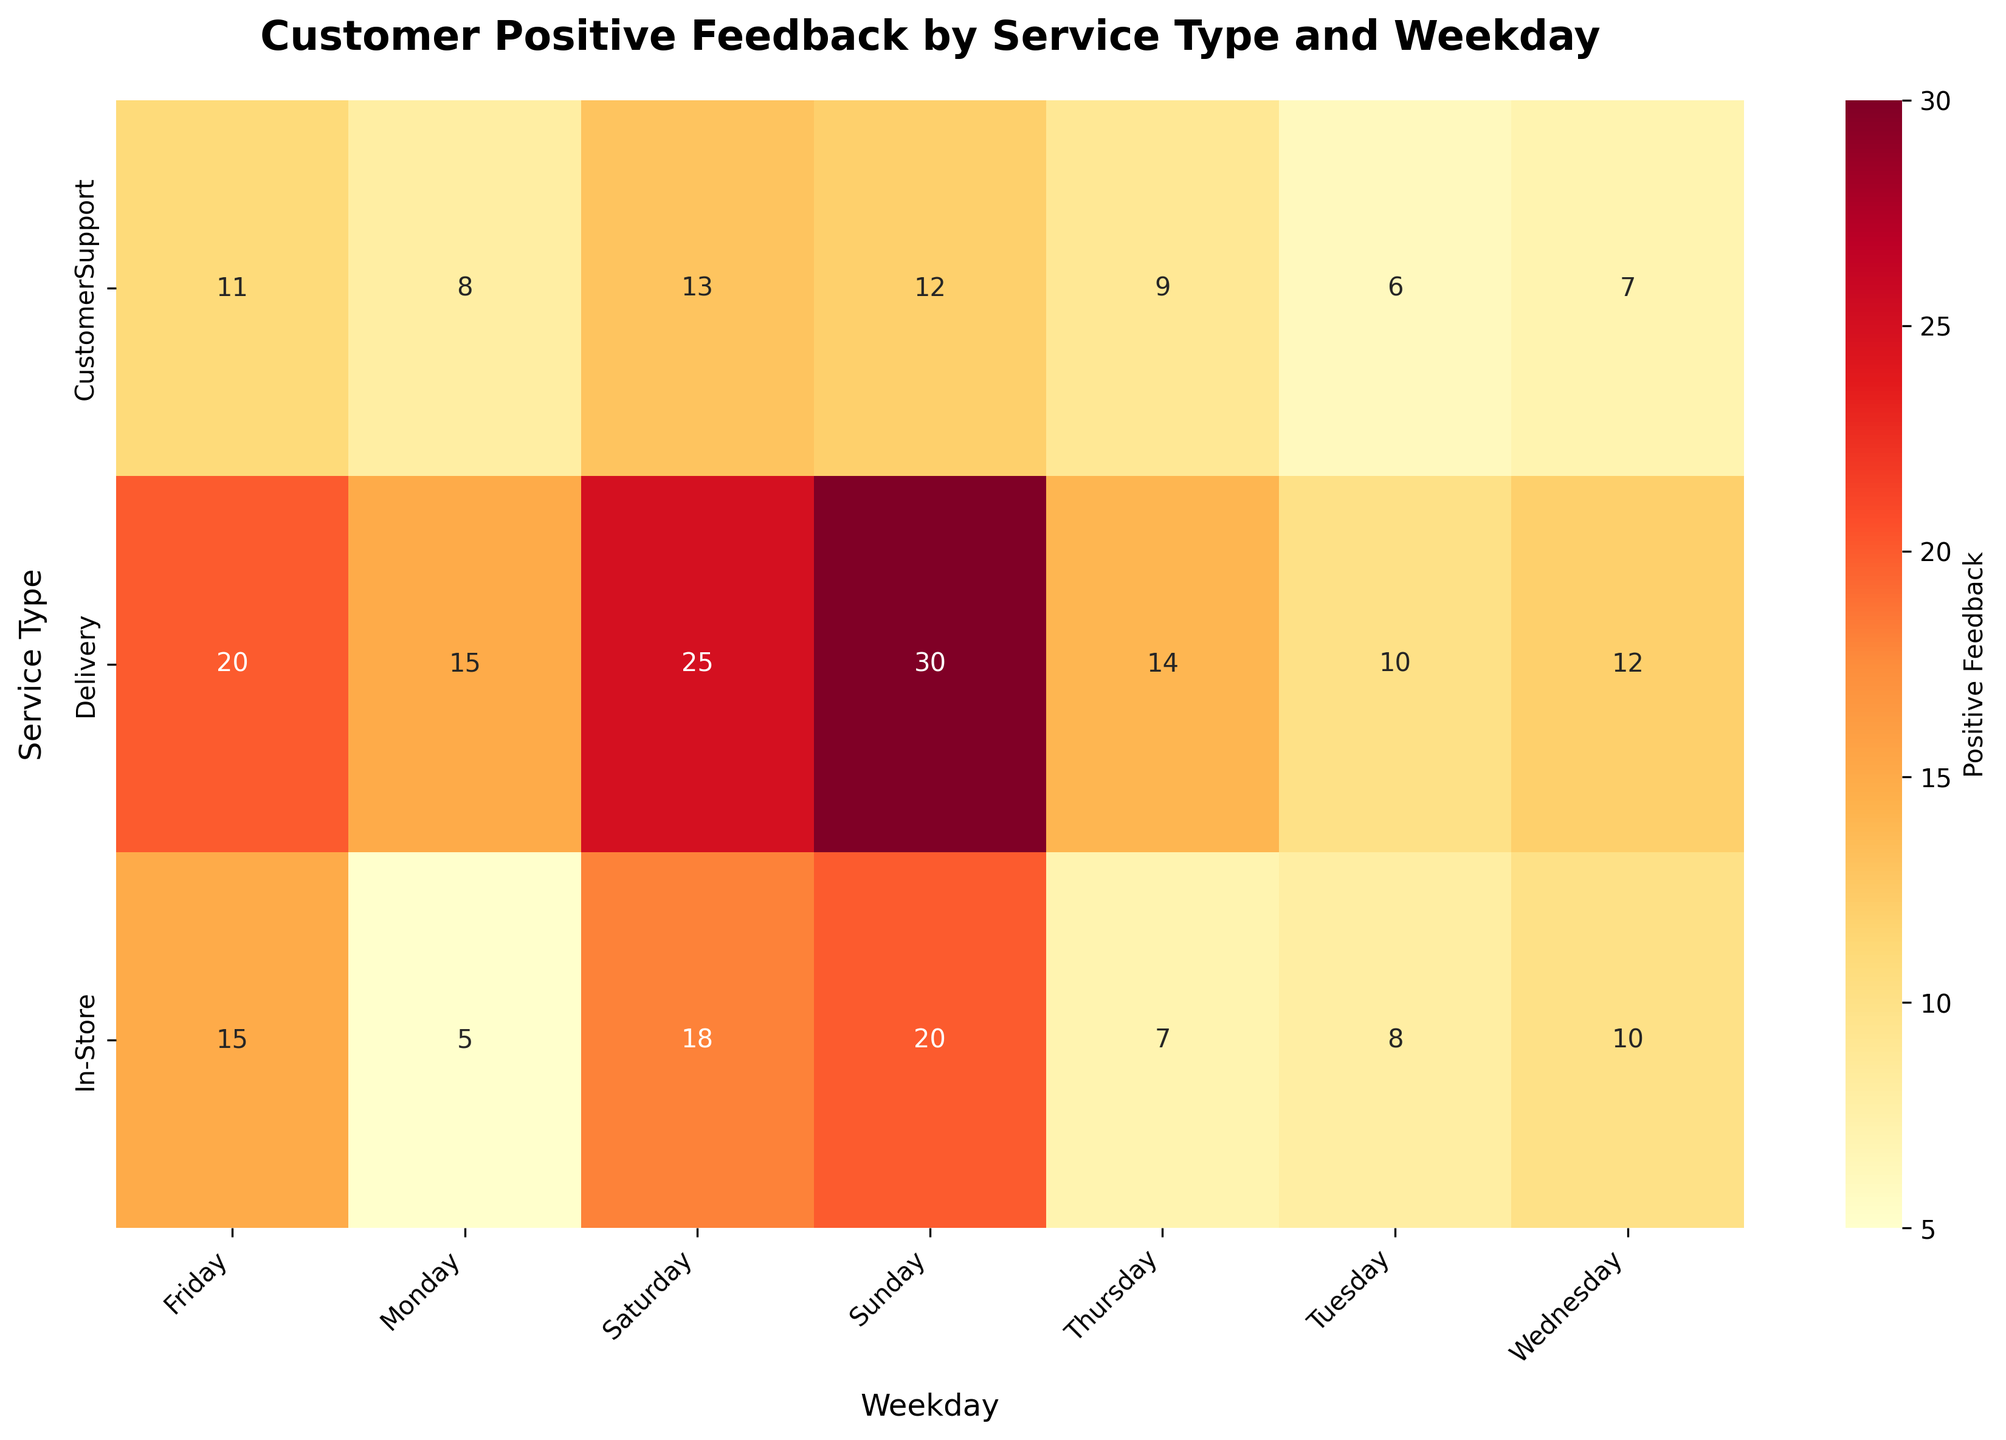Who received the highest positive feedback on Sunday? To determine the service type with the highest positive feedback on Sunday, locate the "Sunday" column and identify the service type with the highest value in that column. The highest value is 30 for Delivery.
Answer: Delivery What is the total positive feedback for In-Store services throughout the week? Sum the positive feedback values for In-Store services across all days: (5 + 8 + 10 + 7 + 15 + 18 + 20) = 83.
Answer: 83 Which day had the lowest positive feedback for Customer Support? Locate the row for Customer Support and then identify the column with the smallest value. Tuesday has the lowest value, which is 6.
Answer: Tuesday Is the positive feedback higher for Delivery or In-Store services on Friday? Compare the values in the Friday column for both Delivery and In-Store. Delivery has 20 positive feedbacks, and In-Store has 15 positive feedbacks. Delivery is higher.
Answer: Delivery What is the average positive feedback for Delivery services? Sum the positive feedback values for Delivery services and then divide by the number of days: (15 + 10 + 12 + 14 + 20 + 25 + 30) / 7 = 126 / 7 = 18.
Answer: 18 How much more positive feedback did Delivery get on Saturday compared to In-Store? Subtract the positive feedback for In-Store from the positive feedback for Delivery on Saturday: 25 - 18 = 7.
Answer: 7 Which service type has the most consistent positive feedback across the week? Assess the variability of positive feedback values for each service type across the days. Delivery has a significant range (10-30), In-Store has a range of (5-20), and Customer Support has (6-13). In-Store shows the least variation.
Answer: In-Store If Customer Support received 2 additional positive feedbacks on Monday, what would their new average positive feedback be? First, update the positive feedback value for Monday from 8 to 10. The total positive feedback becomes (10 + 6 + 7 + 9 + 11 + 13 + 12) = 68. Now divide by 7 days: 68 / 7 ≈ 9.71.
Answer: 9.71 What is the difference in positive feedback between the most and least liked days for Customer Support? Identify the maximum and minimum positive feedback values for Customer Support, which are 13 (Saturday) and 6 (Tuesday). The difference is 13 - 6 = 7.
Answer: 7 